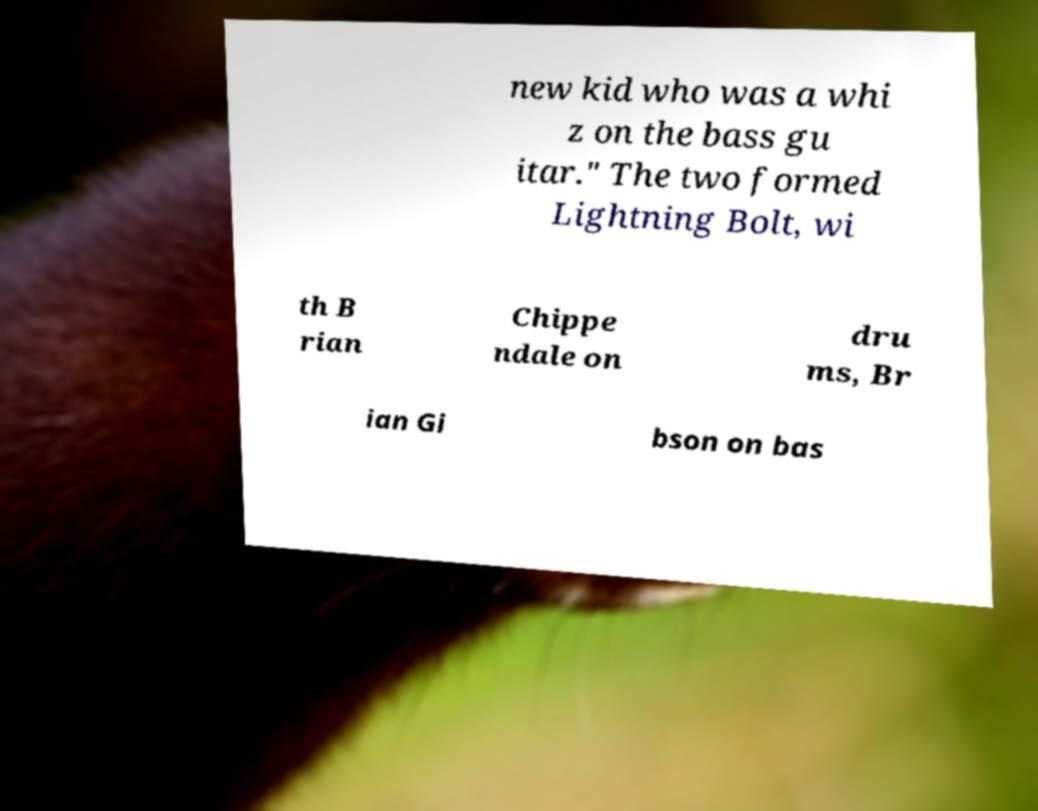I need the written content from this picture converted into text. Can you do that? new kid who was a whi z on the bass gu itar." The two formed Lightning Bolt, wi th B rian Chippe ndale on dru ms, Br ian Gi bson on bas 